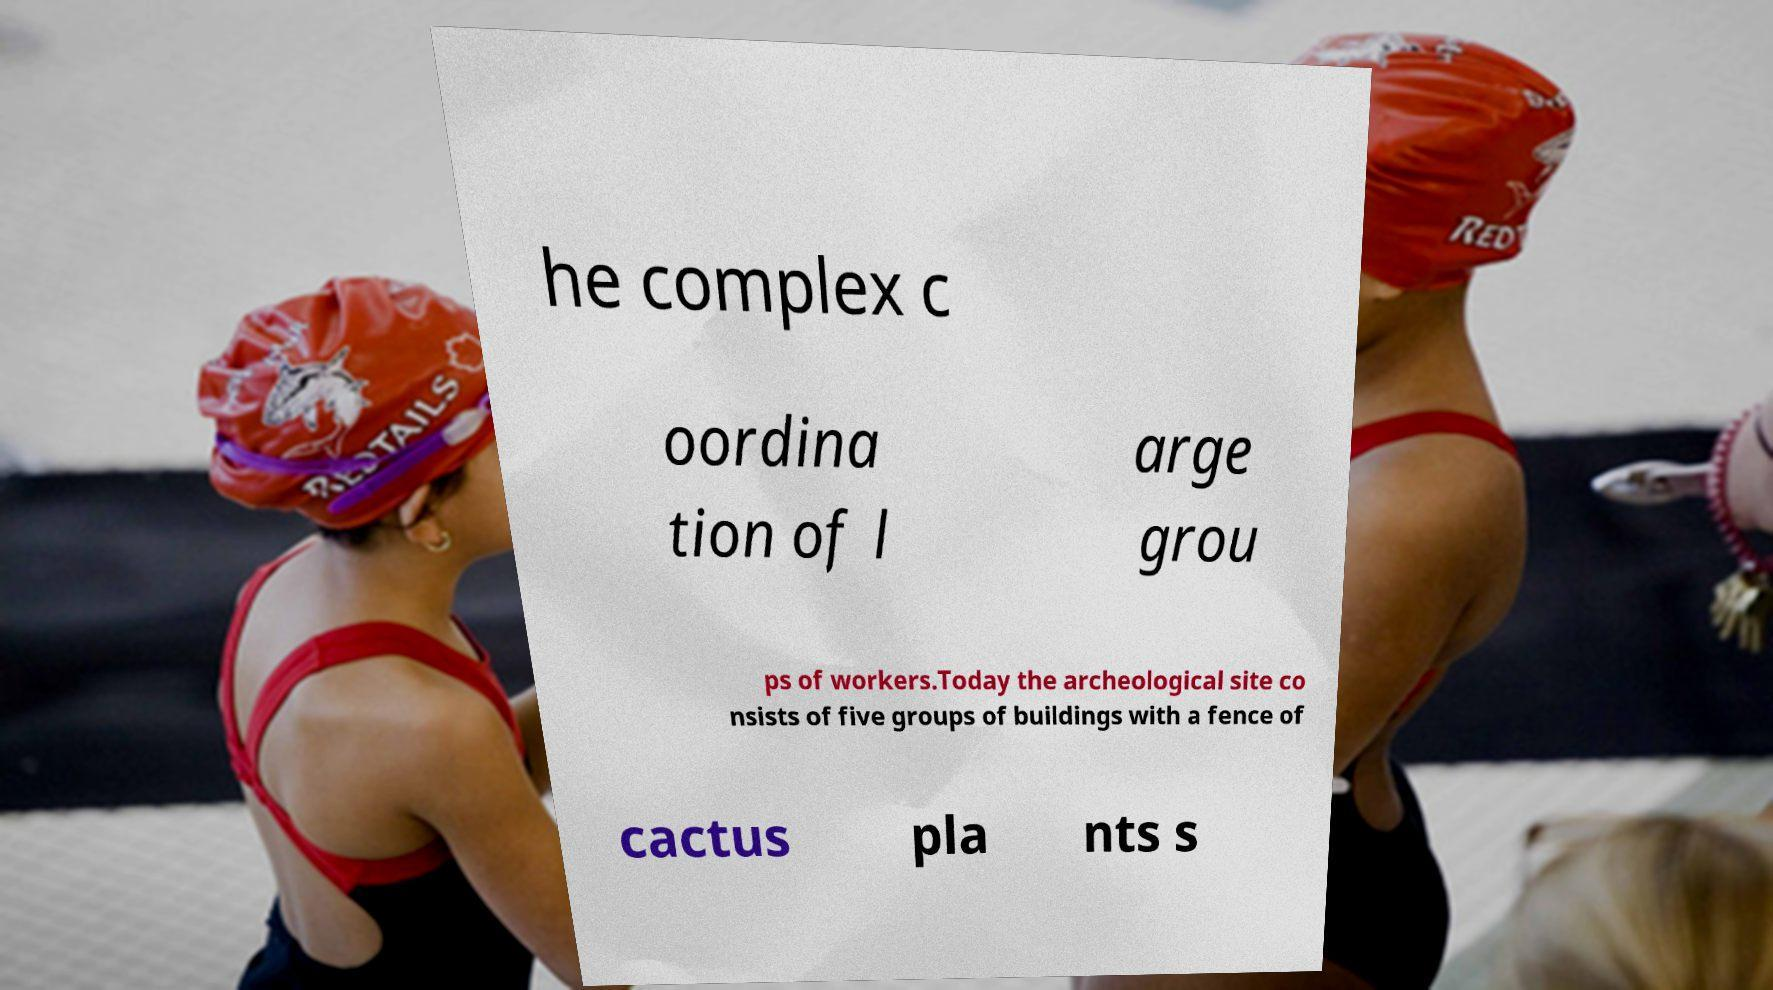Please read and relay the text visible in this image. What does it say? he complex c oordina tion of l arge grou ps of workers.Today the archeological site co nsists of five groups of buildings with a fence of cactus pla nts s 